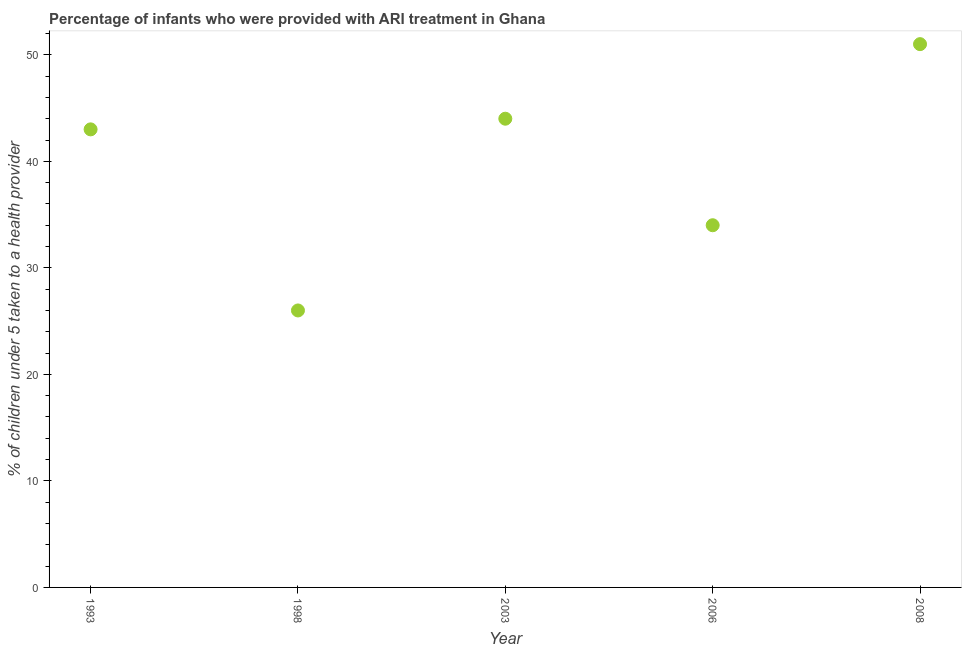What is the percentage of children who were provided with ari treatment in 2006?
Offer a very short reply. 34. Across all years, what is the minimum percentage of children who were provided with ari treatment?
Your response must be concise. 26. In which year was the percentage of children who were provided with ari treatment maximum?
Offer a terse response. 2008. In which year was the percentage of children who were provided with ari treatment minimum?
Your response must be concise. 1998. What is the sum of the percentage of children who were provided with ari treatment?
Offer a very short reply. 198. What is the average percentage of children who were provided with ari treatment per year?
Make the answer very short. 39.6. What is the median percentage of children who were provided with ari treatment?
Give a very brief answer. 43. In how many years, is the percentage of children who were provided with ari treatment greater than 48 %?
Your response must be concise. 1. What is the ratio of the percentage of children who were provided with ari treatment in 1998 to that in 2003?
Your answer should be very brief. 0.59. Is the difference between the percentage of children who were provided with ari treatment in 1998 and 2003 greater than the difference between any two years?
Keep it short and to the point. No. What is the difference between the highest and the lowest percentage of children who were provided with ari treatment?
Your answer should be compact. 25. Does the graph contain any zero values?
Your answer should be very brief. No. Does the graph contain grids?
Offer a terse response. No. What is the title of the graph?
Provide a short and direct response. Percentage of infants who were provided with ARI treatment in Ghana. What is the label or title of the Y-axis?
Offer a very short reply. % of children under 5 taken to a health provider. What is the % of children under 5 taken to a health provider in 1993?
Offer a very short reply. 43. What is the % of children under 5 taken to a health provider in 2003?
Offer a terse response. 44. What is the % of children under 5 taken to a health provider in 2008?
Ensure brevity in your answer.  51. What is the difference between the % of children under 5 taken to a health provider in 1993 and 1998?
Ensure brevity in your answer.  17. What is the difference between the % of children under 5 taken to a health provider in 1993 and 2003?
Make the answer very short. -1. What is the difference between the % of children under 5 taken to a health provider in 1993 and 2008?
Ensure brevity in your answer.  -8. What is the difference between the % of children under 5 taken to a health provider in 1998 and 2003?
Your answer should be compact. -18. What is the difference between the % of children under 5 taken to a health provider in 1998 and 2006?
Offer a very short reply. -8. What is the difference between the % of children under 5 taken to a health provider in 1998 and 2008?
Offer a very short reply. -25. What is the difference between the % of children under 5 taken to a health provider in 2003 and 2006?
Your response must be concise. 10. What is the difference between the % of children under 5 taken to a health provider in 2003 and 2008?
Make the answer very short. -7. What is the difference between the % of children under 5 taken to a health provider in 2006 and 2008?
Offer a very short reply. -17. What is the ratio of the % of children under 5 taken to a health provider in 1993 to that in 1998?
Your answer should be compact. 1.65. What is the ratio of the % of children under 5 taken to a health provider in 1993 to that in 2006?
Make the answer very short. 1.26. What is the ratio of the % of children under 5 taken to a health provider in 1993 to that in 2008?
Your answer should be compact. 0.84. What is the ratio of the % of children under 5 taken to a health provider in 1998 to that in 2003?
Offer a very short reply. 0.59. What is the ratio of the % of children under 5 taken to a health provider in 1998 to that in 2006?
Provide a short and direct response. 0.77. What is the ratio of the % of children under 5 taken to a health provider in 1998 to that in 2008?
Ensure brevity in your answer.  0.51. What is the ratio of the % of children under 5 taken to a health provider in 2003 to that in 2006?
Your answer should be very brief. 1.29. What is the ratio of the % of children under 5 taken to a health provider in 2003 to that in 2008?
Your response must be concise. 0.86. What is the ratio of the % of children under 5 taken to a health provider in 2006 to that in 2008?
Keep it short and to the point. 0.67. 